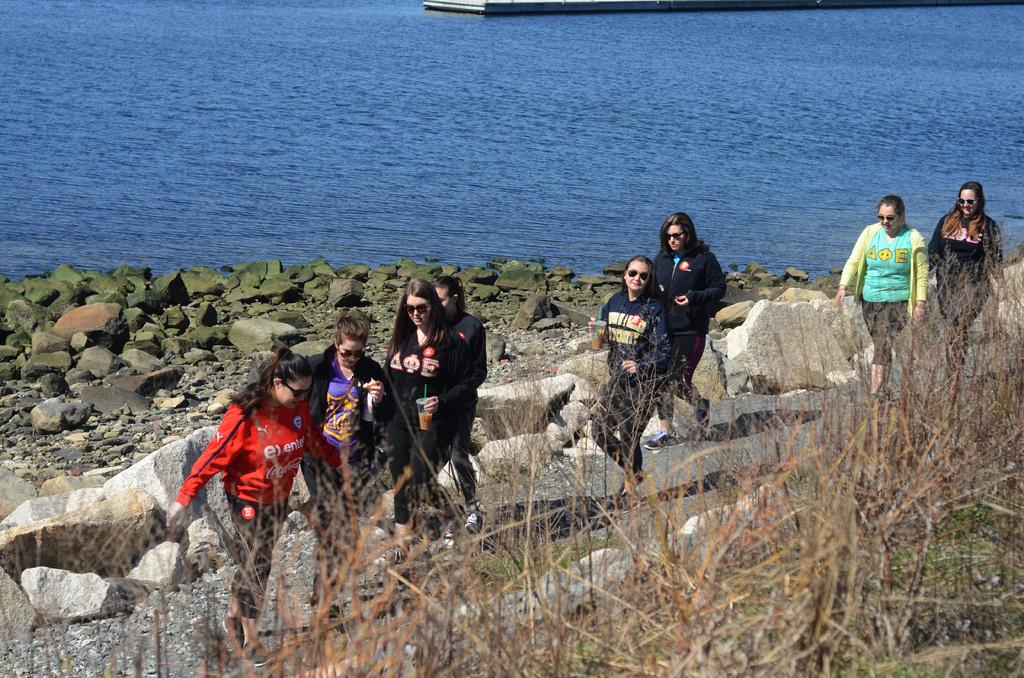Who or what is present in the image? There are people in the image. What are the people wearing? The people are wearing goggles. What type of terrain can be seen in the image? There are rocks and grass visible in the image. What can be seen in the background of the image? There is water visible in the background of the image. What type of hope can be seen floating on the water in the image? There is no hope visible in the image, as hope is an abstract concept and not a physical object that can be seen. 